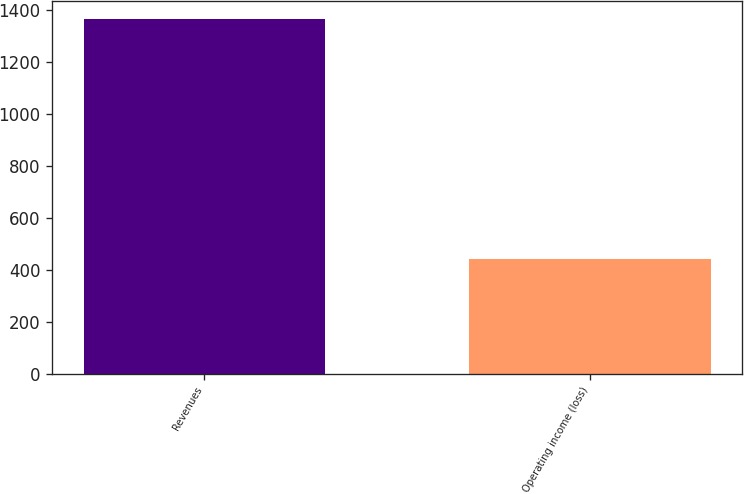Convert chart to OTSL. <chart><loc_0><loc_0><loc_500><loc_500><bar_chart><fcel>Revenues<fcel>Operating income (loss)<nl><fcel>1366<fcel>442<nl></chart> 